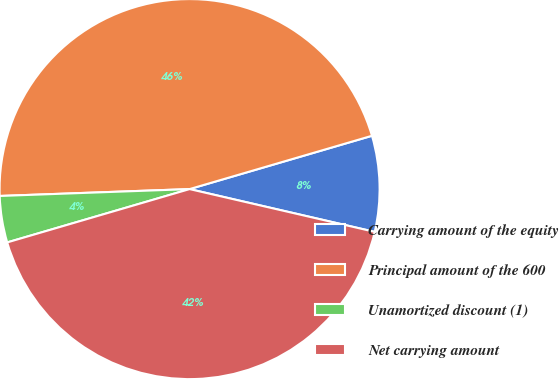Convert chart to OTSL. <chart><loc_0><loc_0><loc_500><loc_500><pie_chart><fcel>Carrying amount of the equity<fcel>Principal amount of the 600<fcel>Unamortized discount (1)<fcel>Net carrying amount<nl><fcel>8.14%<fcel>46.05%<fcel>3.95%<fcel>41.86%<nl></chart> 